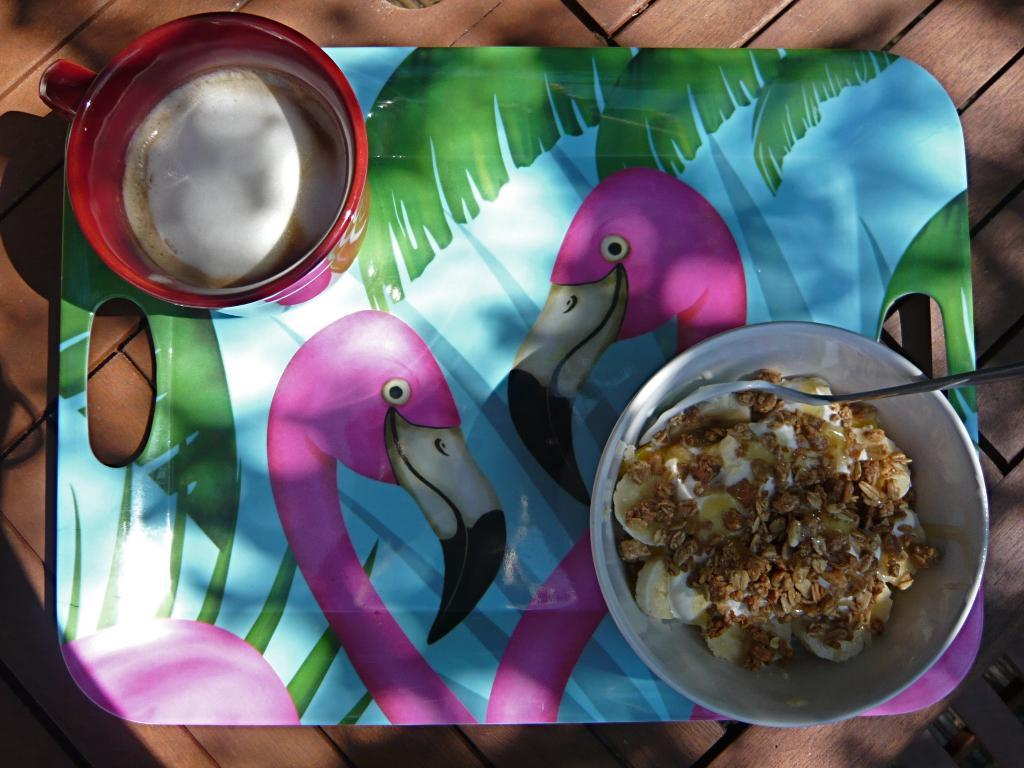What object is present in the image that is used for holding items? There is a tray in the image that is used for holding items. Where is the tray located in the image? The tray is placed on a table in the image. What can be found on the tray? There is a cup and a bowl on the tray. What is in the bowl? There is food in the bowl. What utensil is present in the bowl? There is a spoon in the bowl. Can you tell me how many strangers are sitting on the wing in the image? There is no wing or strangers present in the image. 